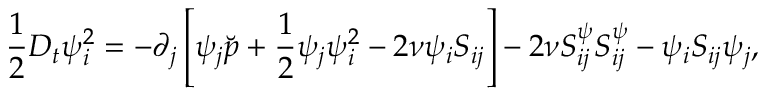Convert formula to latex. <formula><loc_0><loc_0><loc_500><loc_500>\frac { 1 } { 2 } D _ { t } { \psi } _ { i } ^ { 2 } = - \partial _ { j } \left [ { \psi } _ { j } \breve { p } + \frac { 1 } { 2 } { \psi } _ { j } { \psi } _ { i } ^ { 2 } - 2 \nu { \psi } _ { i } S _ { i j } \right ] - 2 \nu S _ { i j } ^ { \psi } S _ { i j } ^ { \psi } - { \psi } _ { i } S _ { i j } { \psi } _ { j } ,</formula> 